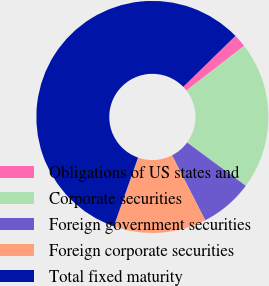<chart> <loc_0><loc_0><loc_500><loc_500><pie_chart><fcel>Obligations of US states and<fcel>Corporate securities<fcel>Foreign government securities<fcel>Foreign corporate securities<fcel>Total fixed maturity<nl><fcel>1.82%<fcel>20.6%<fcel>7.37%<fcel>12.92%<fcel>57.29%<nl></chart> 